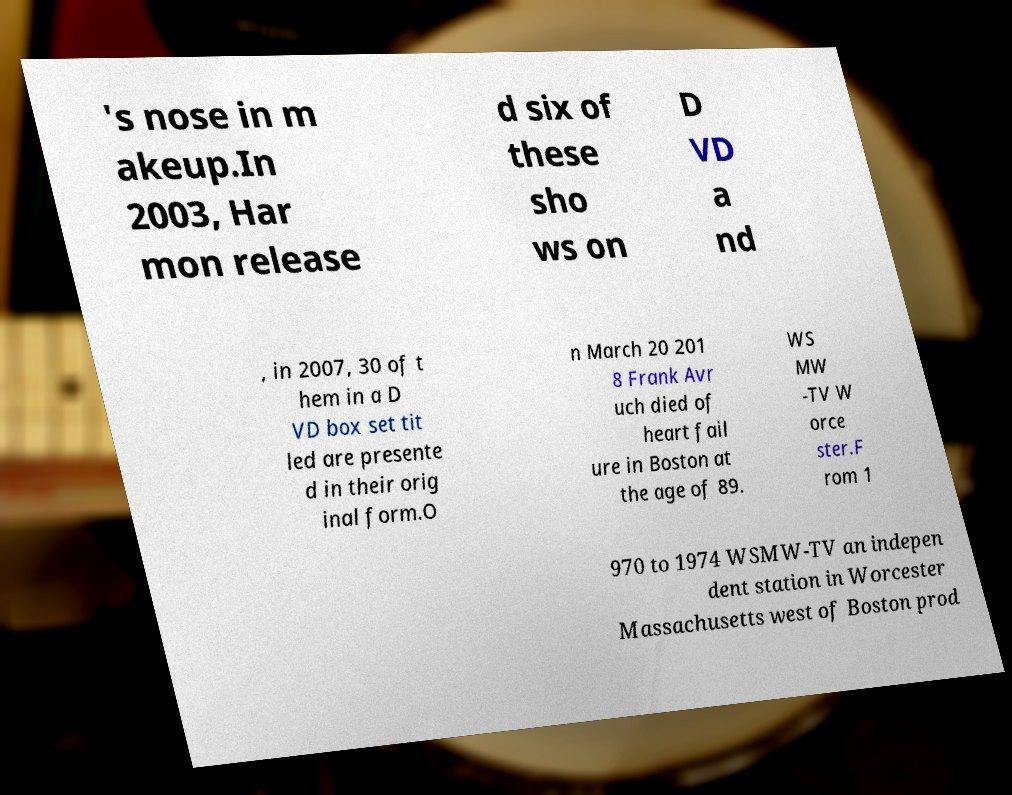Could you extract and type out the text from this image? 's nose in m akeup.In 2003, Har mon release d six of these sho ws on D VD a nd , in 2007, 30 of t hem in a D VD box set tit led are presente d in their orig inal form.O n March 20 201 8 Frank Avr uch died of heart fail ure in Boston at the age of 89. WS MW -TV W orce ster.F rom 1 970 to 1974 WSMW-TV an indepen dent station in Worcester Massachusetts west of Boston prod 